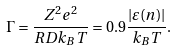<formula> <loc_0><loc_0><loc_500><loc_500>\Gamma = \frac { Z ^ { 2 } e ^ { 2 } } { R D k _ { B } T } = 0 . 9 \frac { | \varepsilon ( n ) | } { k _ { B } T } .</formula> 